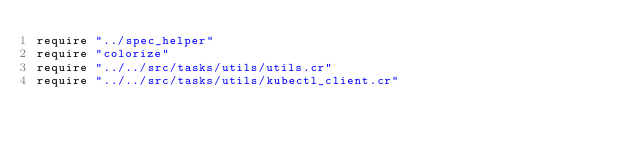Convert code to text. <code><loc_0><loc_0><loc_500><loc_500><_Crystal_>require "../spec_helper"
require "colorize"
require "../../src/tasks/utils/utils.cr"
require "../../src/tasks/utils/kubectl_client.cr"</code> 